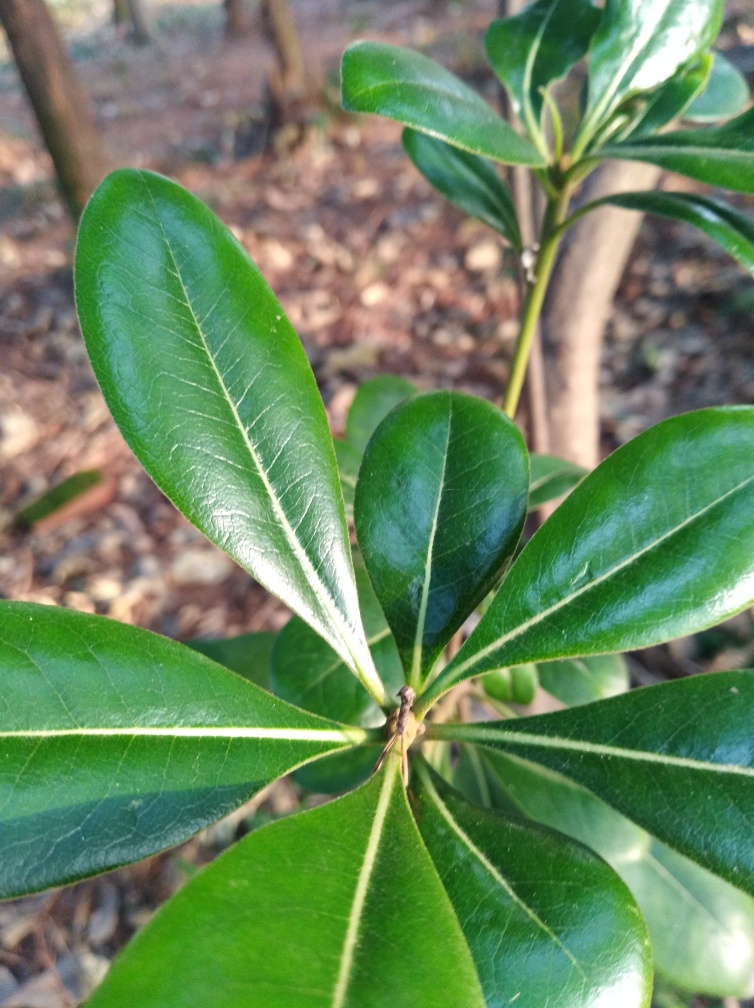What species of plant is this? This appears to be a magnolia plant, characterized by its glossy, evergreen leaves with a robust and waxy texture. Is this plant native to any particular region? Magnolia plants are native to East Asia and the Americas, particularly prevalent in the southeastern United States, Central America, and parts of South America. 